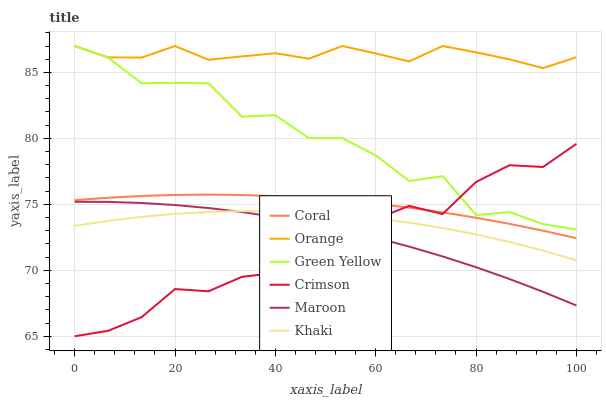Does Crimson have the minimum area under the curve?
Answer yes or no. Yes. Does Orange have the maximum area under the curve?
Answer yes or no. Yes. Does Coral have the minimum area under the curve?
Answer yes or no. No. Does Coral have the maximum area under the curve?
Answer yes or no. No. Is Coral the smoothest?
Answer yes or no. Yes. Is Crimson the roughest?
Answer yes or no. Yes. Is Maroon the smoothest?
Answer yes or no. No. Is Maroon the roughest?
Answer yes or no. No. Does Crimson have the lowest value?
Answer yes or no. Yes. Does Coral have the lowest value?
Answer yes or no. No. Does Green Yellow have the highest value?
Answer yes or no. Yes. Does Coral have the highest value?
Answer yes or no. No. Is Maroon less than Coral?
Answer yes or no. Yes. Is Coral greater than Khaki?
Answer yes or no. Yes. Does Crimson intersect Coral?
Answer yes or no. Yes. Is Crimson less than Coral?
Answer yes or no. No. Is Crimson greater than Coral?
Answer yes or no. No. Does Maroon intersect Coral?
Answer yes or no. No. 